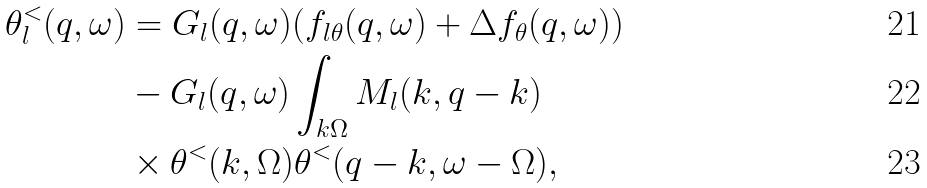Convert formula to latex. <formula><loc_0><loc_0><loc_500><loc_500>\theta ^ { < } _ { l } ( { q } , \omega ) & = G _ { l } ( { q } , \omega ) ( f _ { l \theta } ( { q } , \omega ) + \Delta f _ { \theta } ( { q } , \omega ) ) \\ & - G _ { l } ( { q } , \omega ) \int _ { k \Omega } M _ { l } ( { k } , { q } - { k } ) \\ & \times \theta ^ { < } ( { k } , \Omega ) \theta ^ { < } ( { q } - { k } , \omega - \Omega ) ,</formula> 